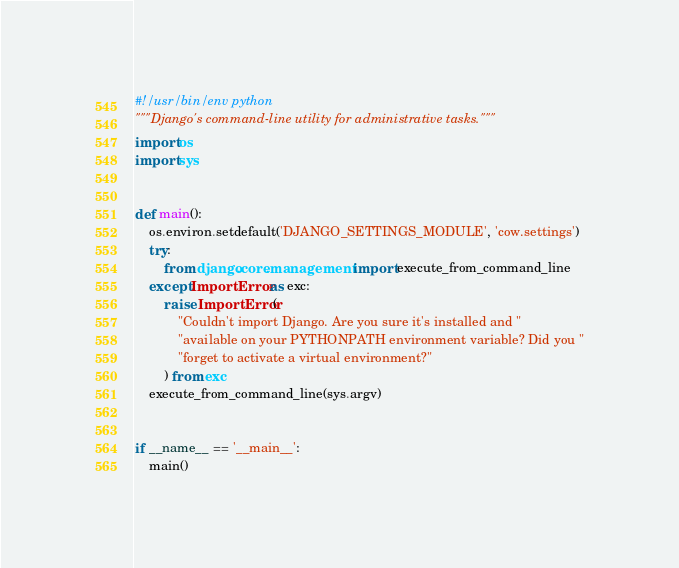<code> <loc_0><loc_0><loc_500><loc_500><_Python_>#!/usr/bin/env python
"""Django's command-line utility for administrative tasks."""
import os
import sys


def main():
    os.environ.setdefault('DJANGO_SETTINGS_MODULE', 'cow.settings')
    try:
        from django.core.management import execute_from_command_line
    except ImportError as exc:
        raise ImportError(
            "Couldn't import Django. Are you sure it's installed and "
            "available on your PYTHONPATH environment variable? Did you "
            "forget to activate a virtual environment?"
        ) from exc
    execute_from_command_line(sys.argv)


if __name__ == '__main__':
    main()
</code> 